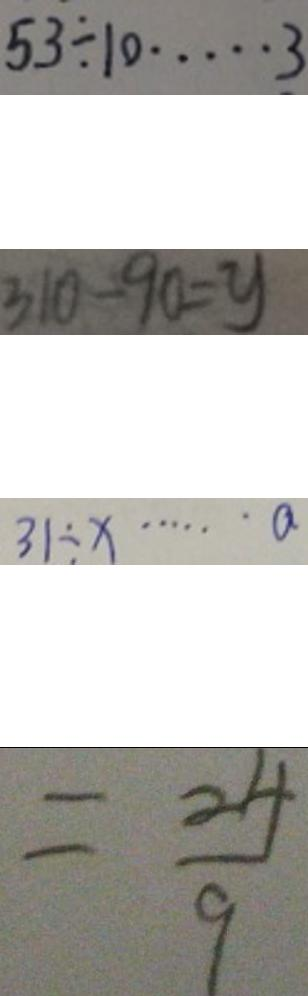<formula> <loc_0><loc_0><loc_500><loc_500>5 3 \div 1 0 \cdots 3 
 3 1 0 - 9 0 = y 
 3 1 \div x \cdots a 
 = \frac { 2 4 } { 9 }</formula> 